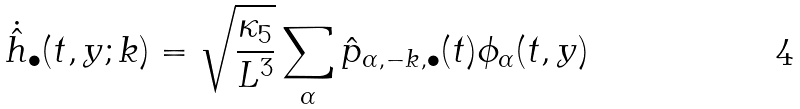<formula> <loc_0><loc_0><loc_500><loc_500>\dot { \hat { h } } _ { \bullet } ( t , y ; { k } ) = \sqrt { \frac { \kappa _ { 5 } } { L ^ { 3 } } } \sum _ { \alpha } \hat { p } _ { \alpha , { - k } , \bullet } ( t ) \phi _ { \alpha } ( t , y )</formula> 